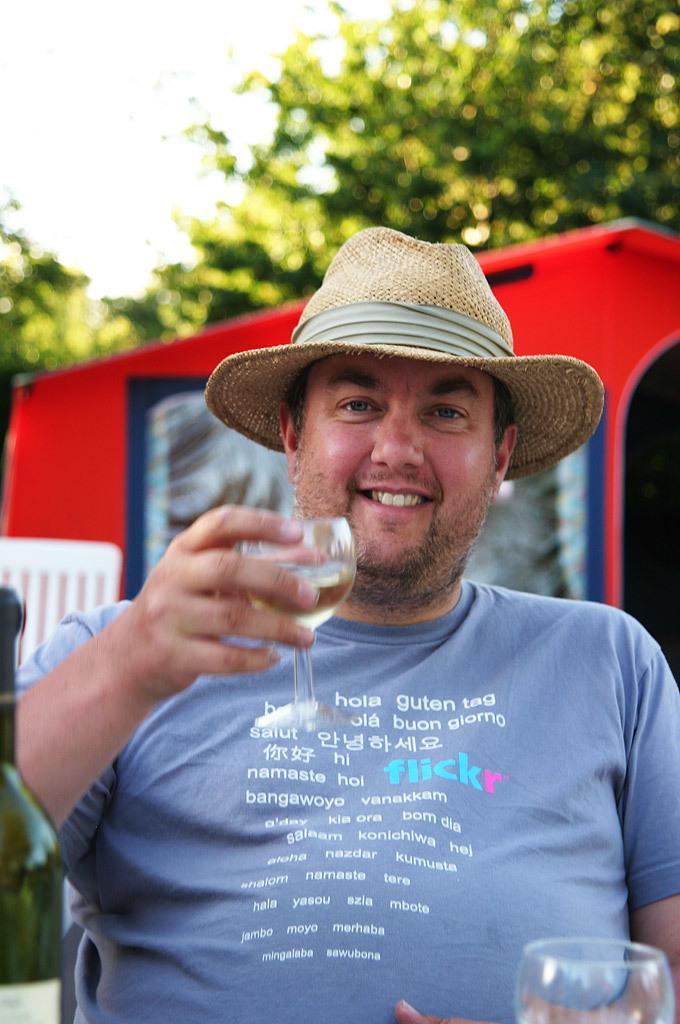Describe this image in one or two sentences. In this picture we can see a man is smiling and holding a glass of drink, he wore a cap, at the right bottom there is another glass, in the background we can see trees, there is the sky at the top of the picture, at the left bottom there is a bottle. 